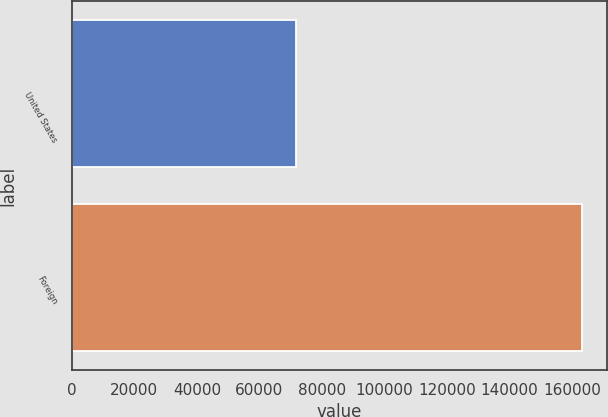<chart> <loc_0><loc_0><loc_500><loc_500><bar_chart><fcel>United States<fcel>Foreign<nl><fcel>71569<fcel>163161<nl></chart> 